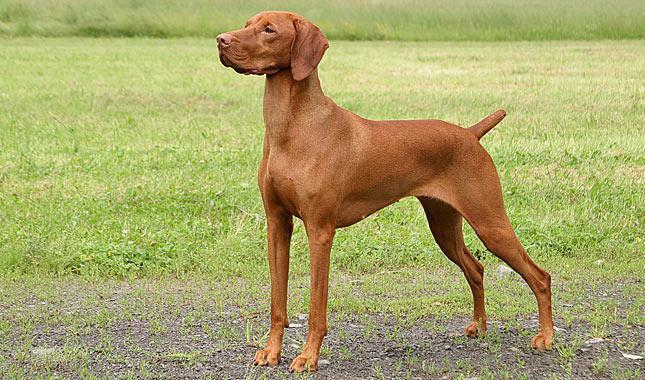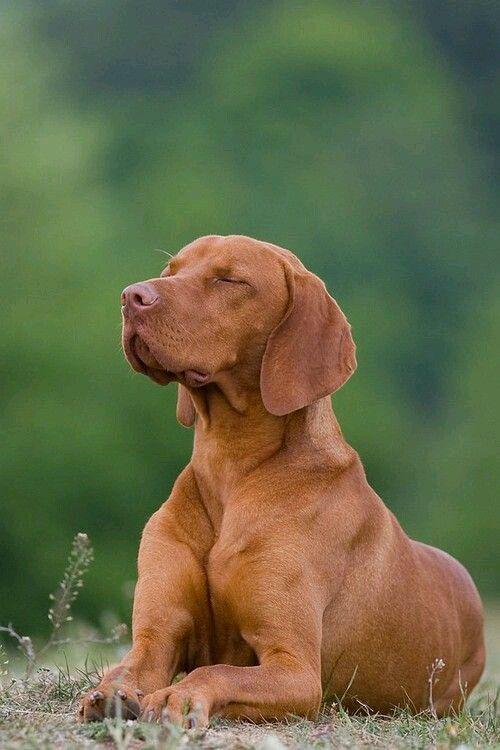The first image is the image on the left, the second image is the image on the right. Considering the images on both sides, is "The dog in one of the images is lying down on the grass." valid? Answer yes or no. Yes. The first image is the image on the left, the second image is the image on the right. For the images displayed, is the sentence "At least one dog is outside facing left." factually correct? Answer yes or no. Yes. 